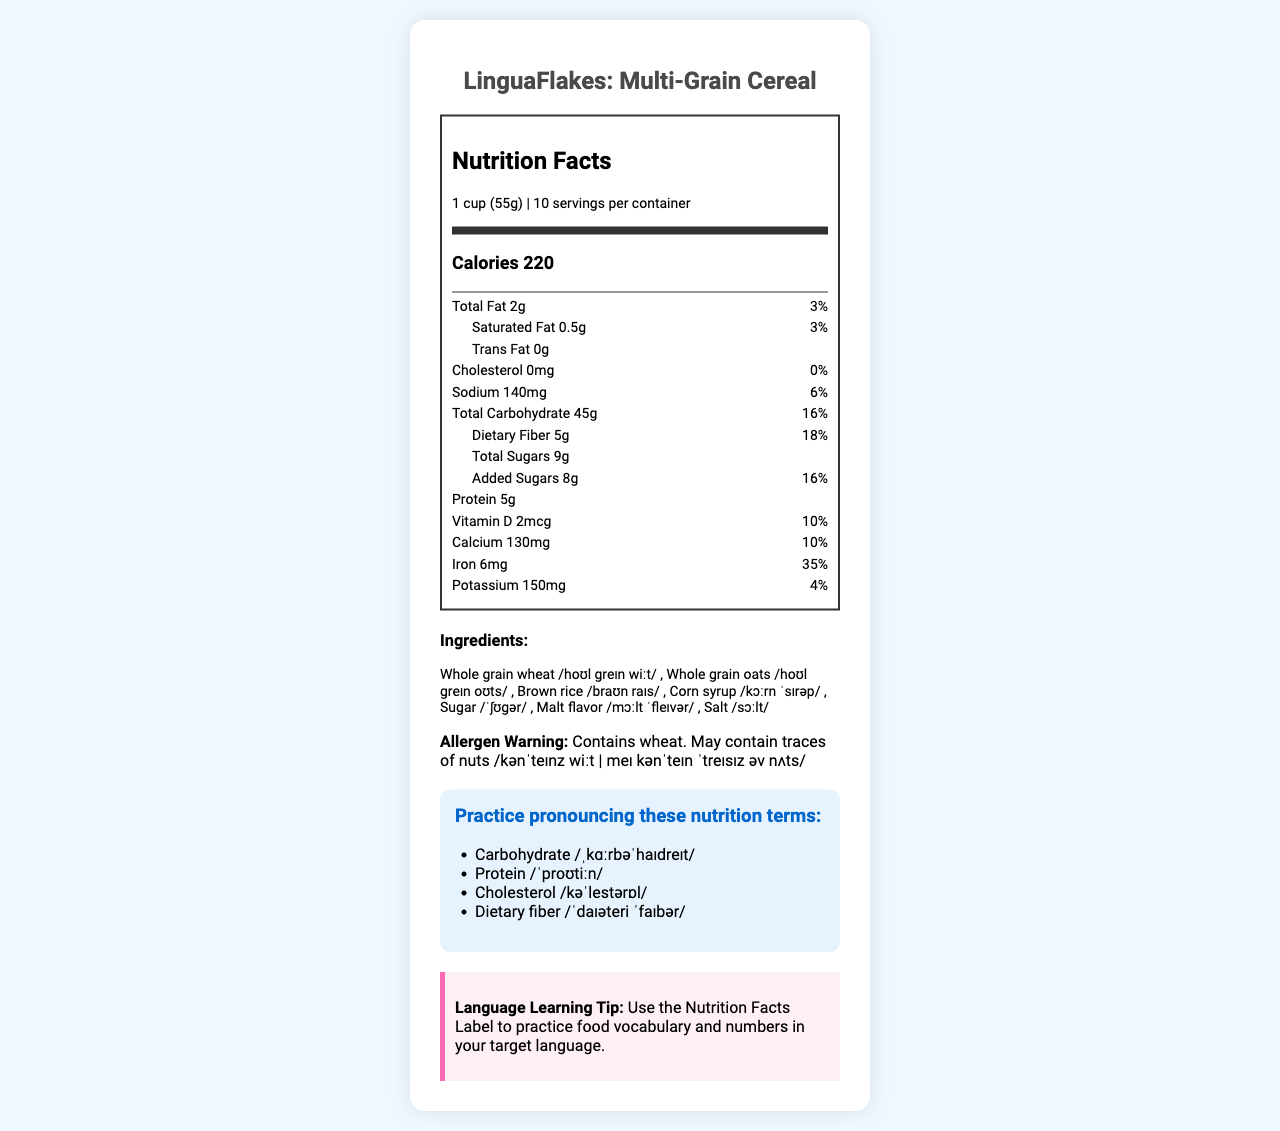What is the serving size of LinguaFlakes? The document states the serving size as "1 cup (55g)" in the Nutrition Facts section.
Answer: 1 cup (55g) How many servings are there in one container of LinguaFlakes? The document specifies that there are 10 servings per container.
Answer: 10 How much saturated fat is there in one serving? Under the nutrient information, it indicates there is 0.5g of saturated fat per serving.
Answer: 0.5g Is LinguaFlakes cholesterol-free? The document states there is 0% cholesterol in one serving, meaning it is cholesterol-free.
Answer: Yes Which nutrient has the highest daily value percentage? The daily value for iron is the highest at 35% as listed in the nutrient information section.
Answer: Iron Does LinguaFlakes contain any allergens? The allergen warning states that it contains wheat and may contain traces of nuts.
Answer: Yes What are the main ingredients in LinguaFlakes? The ingredients are listed in the ingredients section, each with its corresponding pronunciation.
Answer: Whole grain wheat, Whole grain oats, Brown rice, Corn syrup, Sugar, Malt flavor, Salt What is the calorie count for one serving of LinguaFlakes? The main info section of the Nutrition Facts label indicates that one serving has 220 calories.
Answer: 220 Identify three nutrition claims made for LinguaFlakes. These claims are listed under the nutrition claims practice section.
Answer: Good source of fiber, Low in saturated fat, Cholesterol-free Which of the following nutrients is not listed in the Nutrition Facts? A. Vitamin C B. Vitamin D C. Calcium D. Iron Vitamin C is not included in the listed nutrients, whereas Vitamin D, Calcium, and Iron are mentioned.
Answer: A. Vitamin C How much dietary fiber is there per serving, and what is its daily value percentage? A. 4g, 16% B. 5g, 18% C. 6g, 20% D. 7g, 22% The dietary fiber content per serving is 5g and the daily value percentage is 18%, as listed in the document.
Answer: B. 5g, 18% Is the sugar content per serving higher than the added sugar content in LinguaFlakes? The total sugars per serving are 9g, and the added sugars are 8g. The added sugar content is slightly lower than the total sugar content.
Answer: No Summarize the main information provided in the LinguaFlakes Nutrition Facts label. This summary captures all key nutritional information, ingredients, allergens, and claims about the product.
Answer: LinguaFlakes: Multi-Grain Cereal has a serving size of 1 cup (55g) with 10 servings per container and 220 calories per serving. It includes nutrients such as 2g of total fat, 0.5g of saturated fat, 0g trans fat, 0mg cholesterol, 140mg sodium, 45g total carbohydrate, 5g dietary fiber, 9g total sugars, 8g added sugars, 5g protein, 2mcg vitamin D, 130mg calcium, 6mg iron, and 150mg potassium. Ingredients include whole grain wheat, oats, brown rice, corn syrup, sugar, malt flavor, and salt. It contains wheat and may have nut traces while making claims like being a good source of fiber and low in saturated fat. What is the source of protein in LinguaFlakes? The document lists the protein content but does not specify the sources of protein.
Answer: Cannot be determined What is the pronunciation of 'whole grain oats' using IPA symbols from the document? The pronunciation for "whole grain oats" as per the document's ingredients section is /hoʊl greɪn oʊts/.
Answer: /hoʊl greɪn oʊts/ 